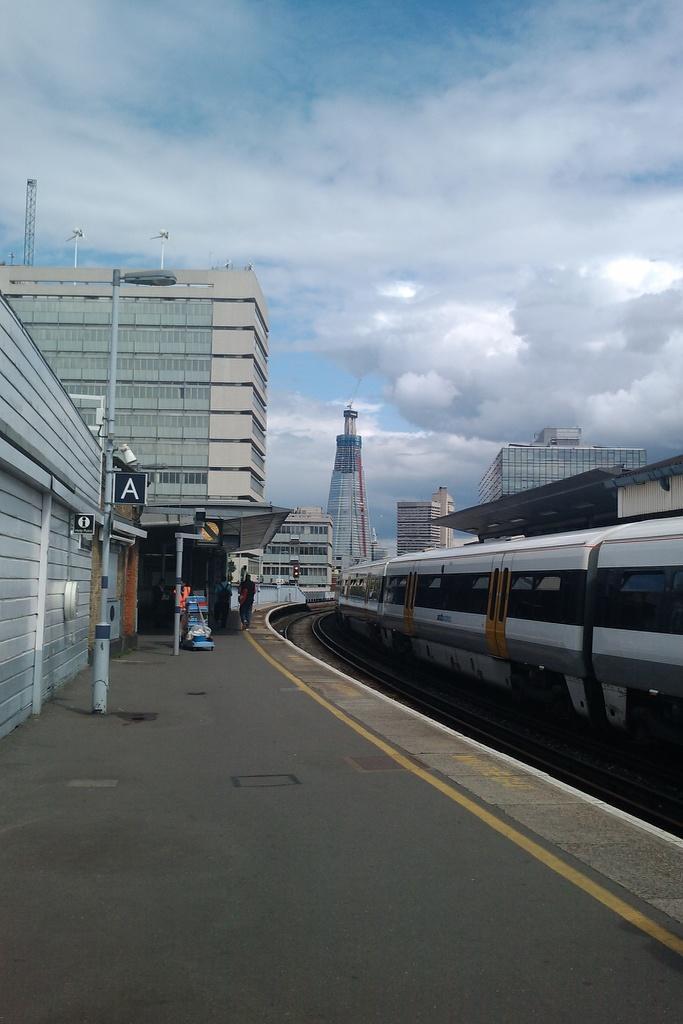Can you describe this image briefly? In the picture we can see a railway station with a platform and on it we can see a pole with light and beside it, we can see a track and a train on it and in the background we can see some buildings and in the background we can see a sky with clouds. 